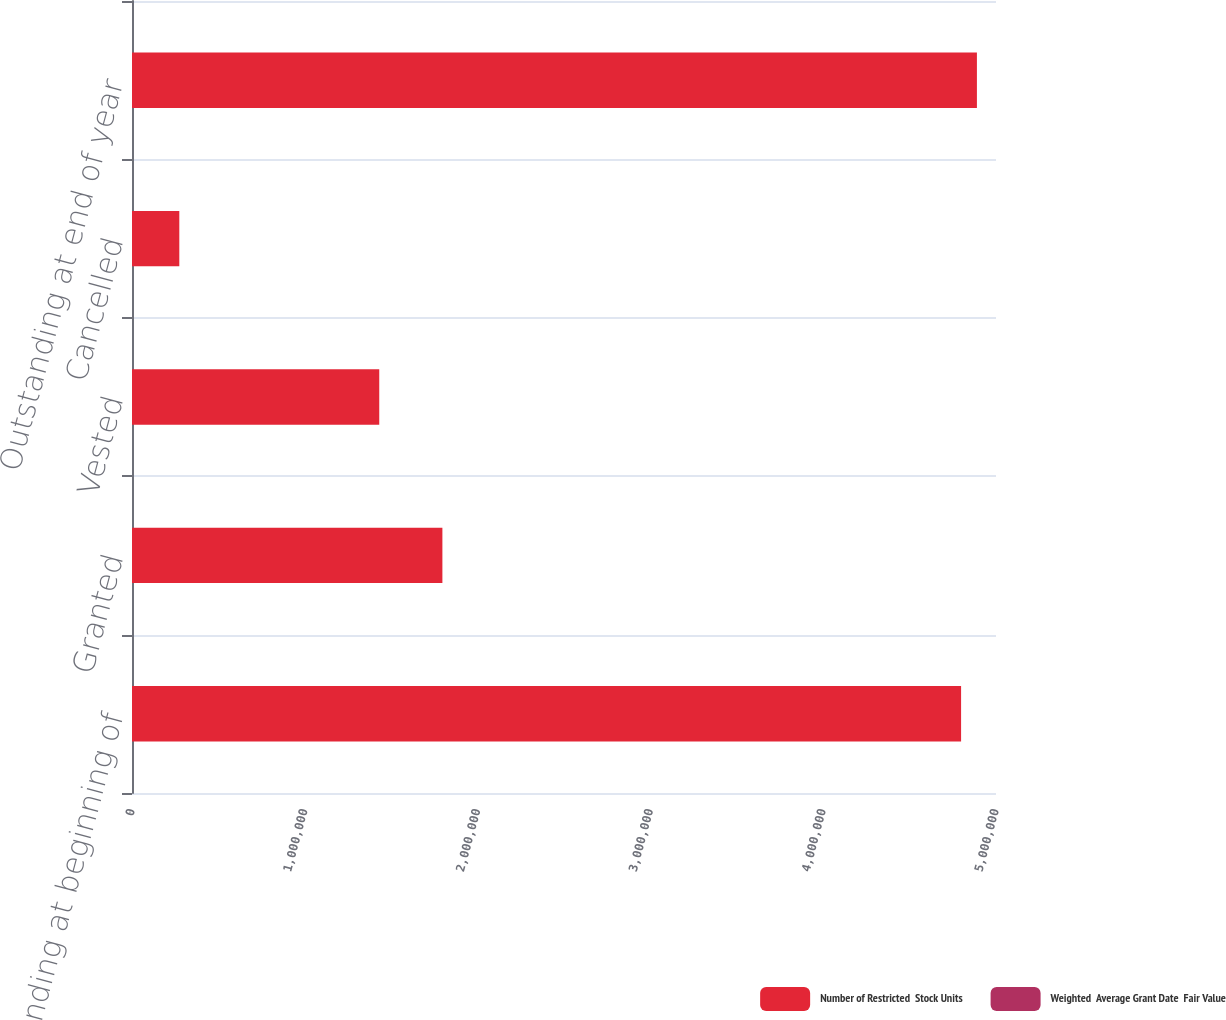<chart> <loc_0><loc_0><loc_500><loc_500><stacked_bar_chart><ecel><fcel>Outstanding at beginning of<fcel>Granted<fcel>Vested<fcel>Cancelled<fcel>Outstanding at end of year<nl><fcel>Number of Restricted  Stock Units<fcel>4.79792e+06<fcel>1.7962e+06<fcel>1.43083e+06<fcel>273762<fcel>4.88953e+06<nl><fcel>Weighted  Average Grant Date  Fair Value<fcel>31.77<fcel>33.75<fcel>29.83<fcel>32.82<fcel>33.01<nl></chart> 